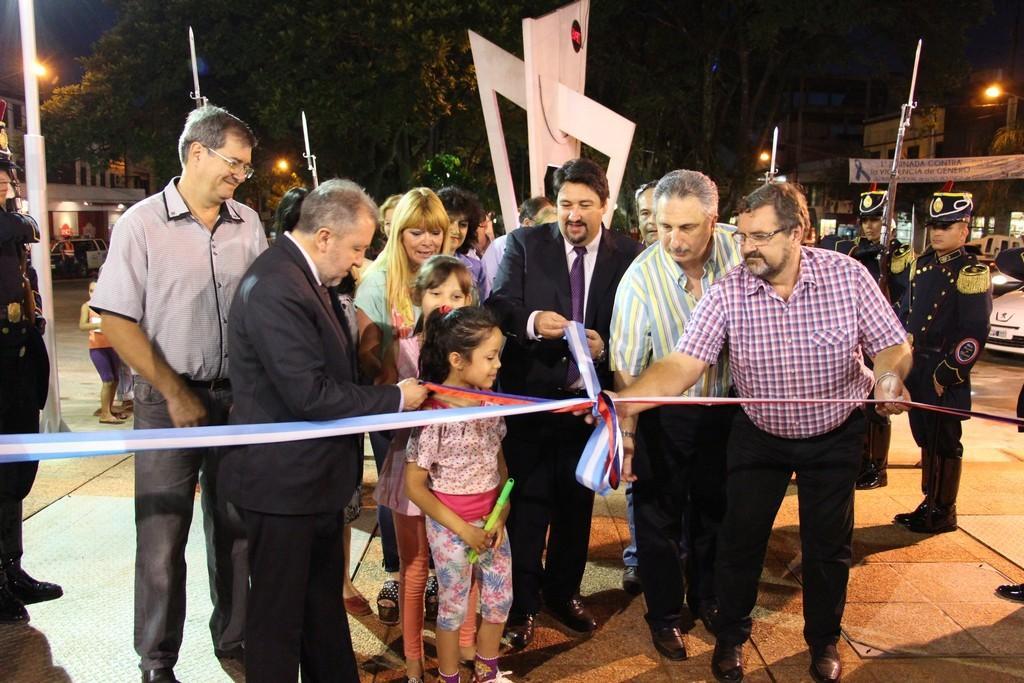How would you summarize this image in a sentence or two? In this image I can see a group of people. In the background, I can see trees, building. I can see the lights. 